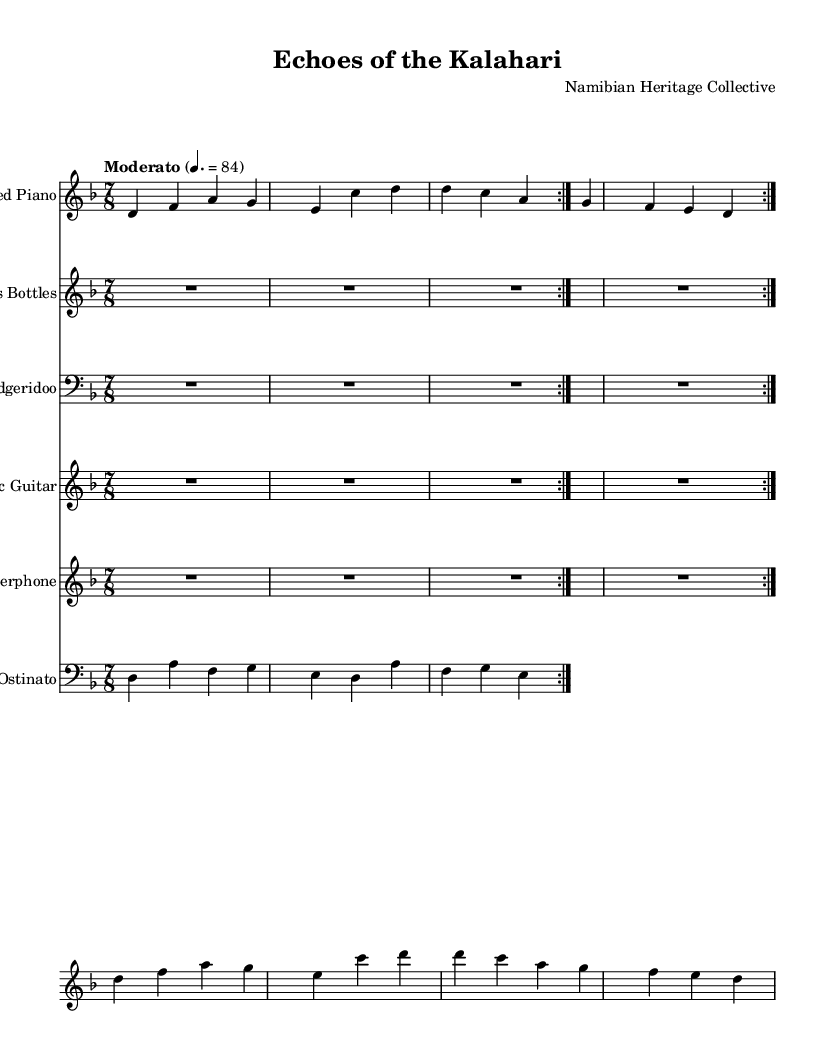What is the key signature of this music? The key signature is D minor, which is indicated by one flat (B♭) on the staff.
Answer: D minor What is the time signature of this music? The time signature is 7/8, shown at the beginning of the score. This means there are 7 beats per measure, with the eighth note getting one beat.
Answer: 7/8 What tempo is indicated for this piece? The tempo marking states "Moderato" with a metronome marking of 84 beats per minute, indicating a moderate pace for the performance.
Answer: Moderato 4. = 84 How many instruments are featured in this arrangement? There are five different instruments used in this score: prepared piano, glass bottles, didgeridoo, electric guitar, and waterphone.
Answer: Five Which section features the main theme? The main theme can be found in the staff labeled "Prepared Piano", specifically in the first two measures before the variation begins.
Answer: Prepared Piano What kind of unconventional instrument is used alongside traditional instruments? The instrument "glass bottles" is an unconventional choice that reflects an innovative approach in this arrangement.
Answer: Glass Bottles What is the rhythmic pattern of the ostinato section? The ostinato section consists of a repeating pattern that follows the notes d a f g e, giving it a unique rhythmic quality that underpins the piece.
Answer: d a f g e 